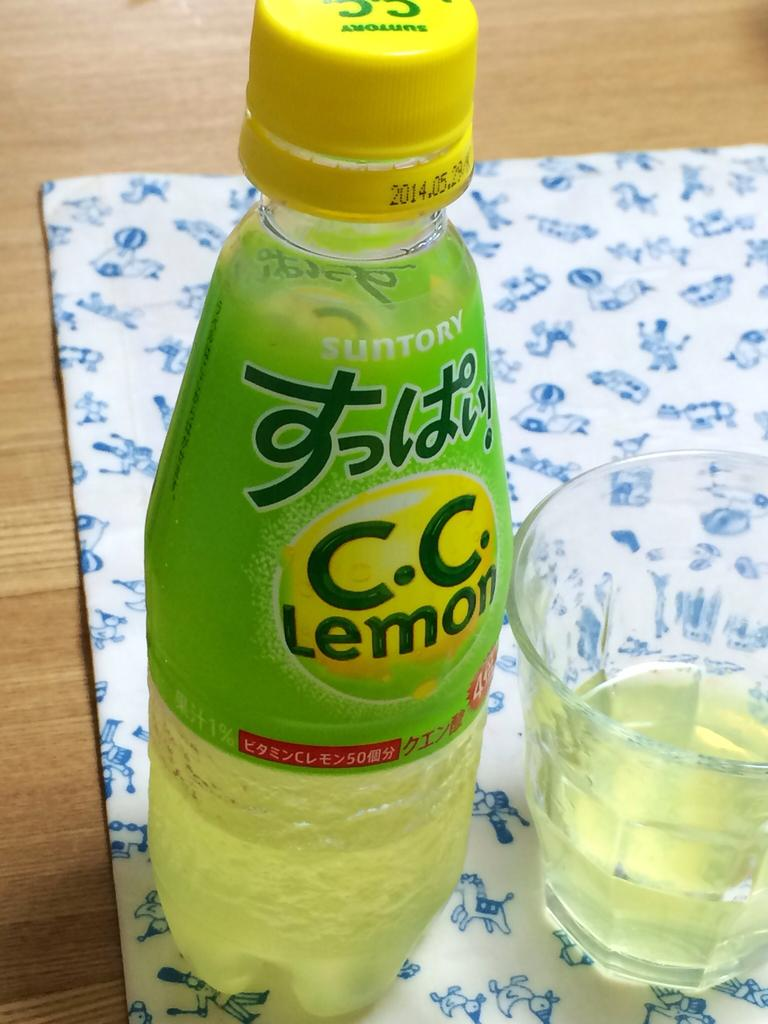<image>
Write a terse but informative summary of the picture. A bottle of Suntory C.C. Lemon sitting on a placemat 